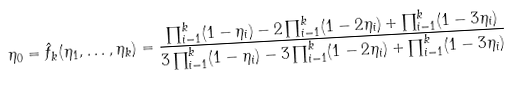Convert formula to latex. <formula><loc_0><loc_0><loc_500><loc_500>\eta _ { 0 } = \hat { f } _ { k } ( \eta _ { 1 } , \dots , \eta _ { k } ) = \frac { \prod _ { i = 1 } ^ { k } ( 1 - \eta _ { i } ) - 2 \prod _ { i = 1 } ^ { k } ( 1 - 2 \eta _ { i } ) + \prod _ { i = 1 } ^ { k } ( 1 - 3 \eta _ { i } ) } { 3 \prod _ { i = 1 } ^ { k } ( 1 - \eta _ { i } ) - 3 \prod _ { i = 1 } ^ { k } ( 1 - 2 \eta _ { i } ) + \prod _ { i = 1 } ^ { k } ( 1 - 3 \eta _ { i } ) }</formula> 